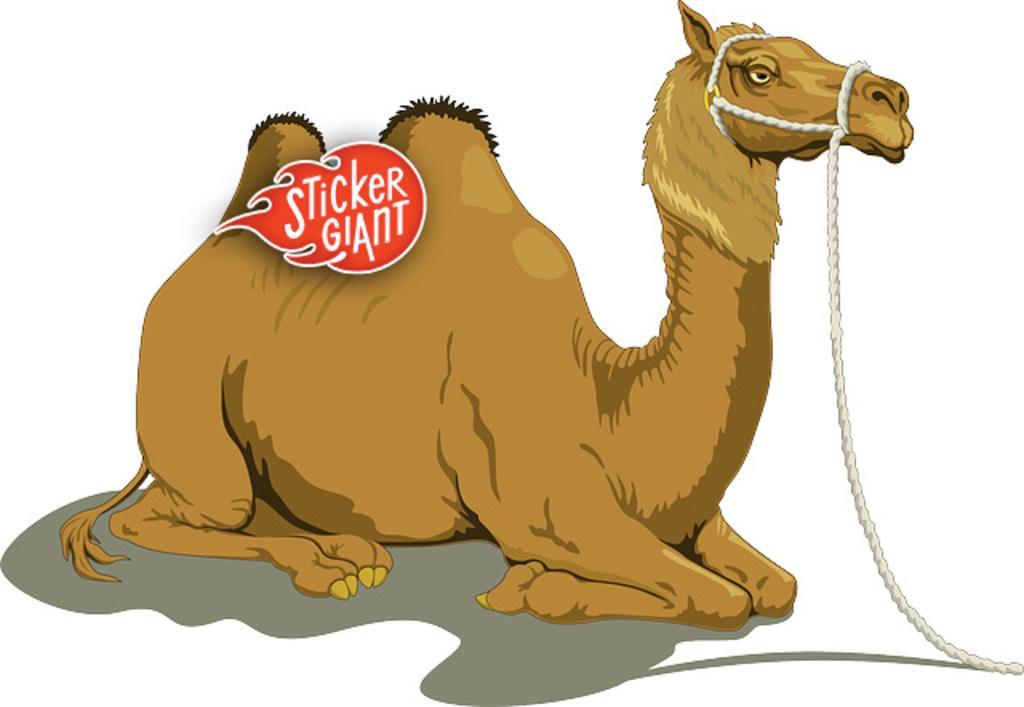Could you give a brief overview of what you see in this image? This is an animation, in this image in the center there is a camel and there is a logo in the foreground, and on the right side there is rope and there is a white background. 